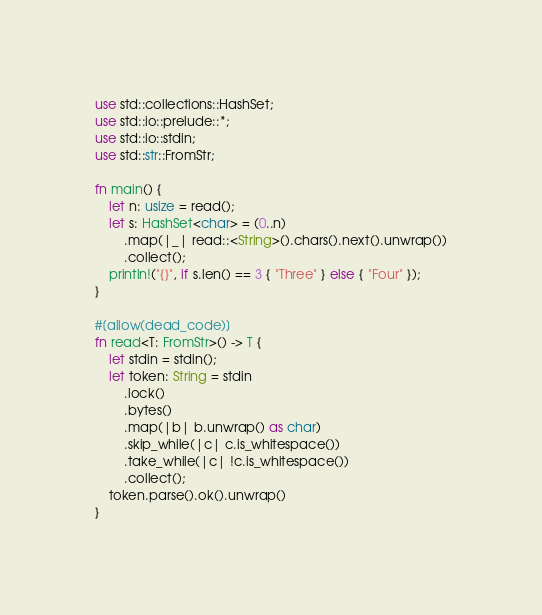Convert code to text. <code><loc_0><loc_0><loc_500><loc_500><_Rust_>use std::collections::HashSet;
use std::io::prelude::*;
use std::io::stdin;
use std::str::FromStr;

fn main() {
    let n: usize = read();
    let s: HashSet<char> = (0..n)
        .map(|_| read::<String>().chars().next().unwrap())
        .collect();
    println!("{}", if s.len() == 3 { "Three" } else { "Four" });
}

#[allow(dead_code)]
fn read<T: FromStr>() -> T {
    let stdin = stdin();
    let token: String = stdin
        .lock()
        .bytes()
        .map(|b| b.unwrap() as char)
        .skip_while(|c| c.is_whitespace())
        .take_while(|c| !c.is_whitespace())
        .collect();
    token.parse().ok().unwrap()
}
</code> 